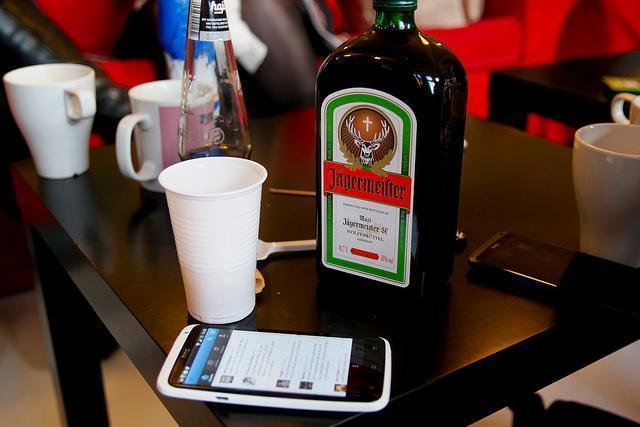How many cups can you see?
Give a very brief answer. 4. How many bottles are in the photo?
Give a very brief answer. 2. How many horses are there?
Give a very brief answer. 0. 